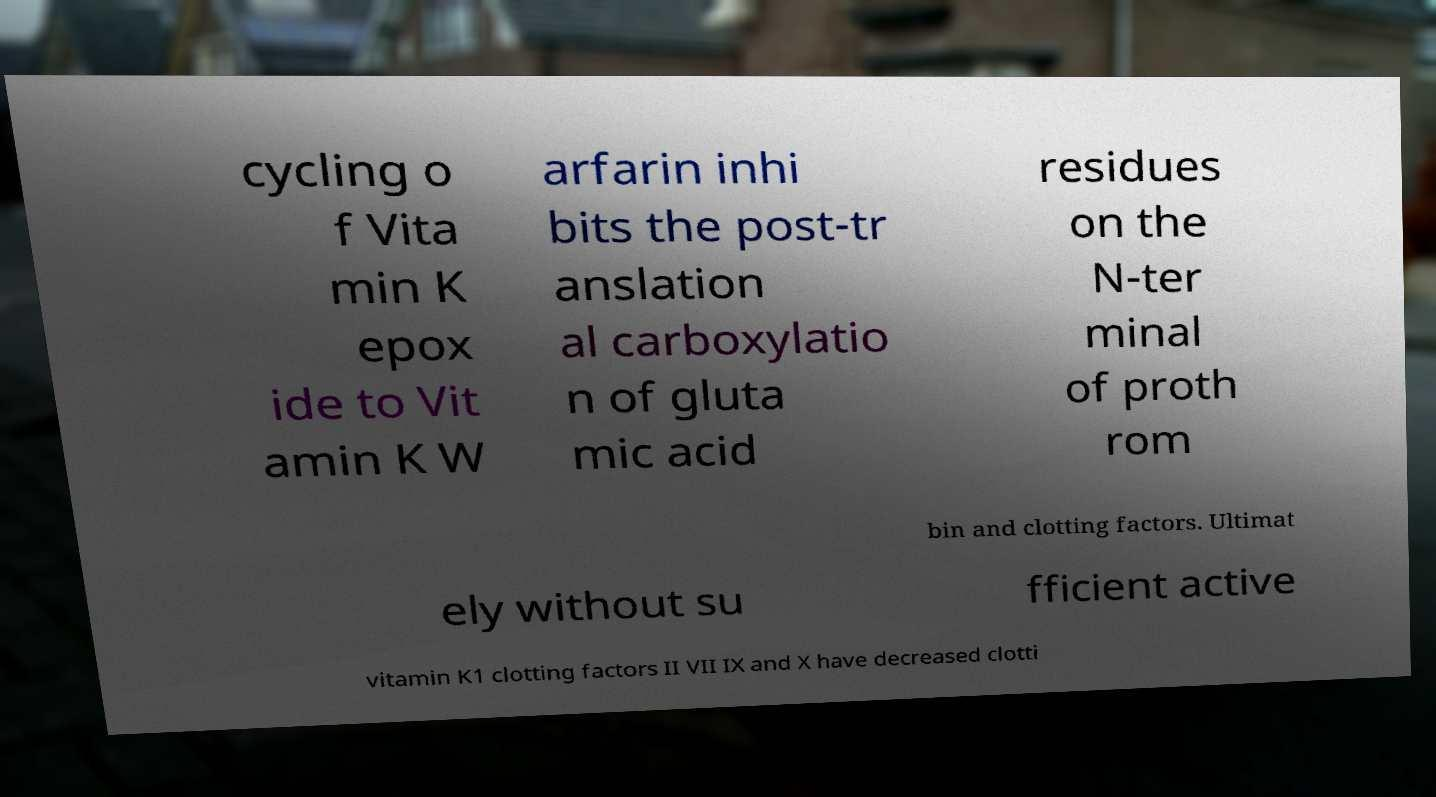Can you accurately transcribe the text from the provided image for me? cycling o f Vita min K epox ide to Vit amin K W arfarin inhi bits the post-tr anslation al carboxylatio n of gluta mic acid residues on the N-ter minal of proth rom bin and clotting factors. Ultimat ely without su fficient active vitamin K1 clotting factors II VII IX and X have decreased clotti 